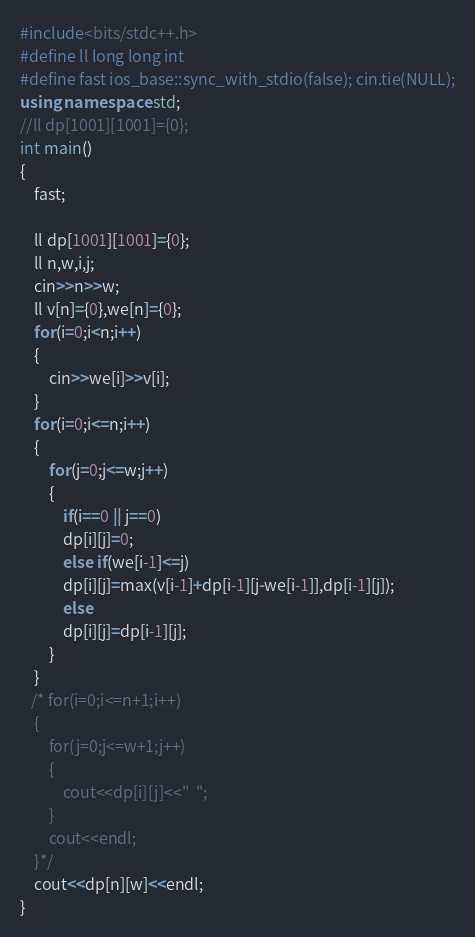<code> <loc_0><loc_0><loc_500><loc_500><_C++_>#include<bits/stdc++.h>
#define ll long long int
#define fast ios_base::sync_with_stdio(false); cin.tie(NULL);
using namespace std;
//ll dp[1001][1001]={0};
int main()
{
    fast;
    
    ll dp[1001][1001]={0};
    ll n,w,i,j;
    cin>>n>>w;
    ll v[n]={0},we[n]={0};
    for(i=0;i<n;i++)
    {
        cin>>we[i]>>v[i];
    }
    for(i=0;i<=n;i++)
    {
        for(j=0;j<=w;j++)
        {
            if(i==0 || j==0)
            dp[i][j]=0;
            else if(we[i-1]<=j)
            dp[i][j]=max(v[i-1]+dp[i-1][j-we[i-1]],dp[i-1][j]);
            else
            dp[i][j]=dp[i-1][j];
        }
    }
   /* for(i=0;i<=n+1;i++)
    {
        for(j=0;j<=w+1;j++)
        {
            cout<<dp[i][j]<<"  ";
        }
        cout<<endl;
    }*/
    cout<<dp[n][w]<<endl;
}</code> 